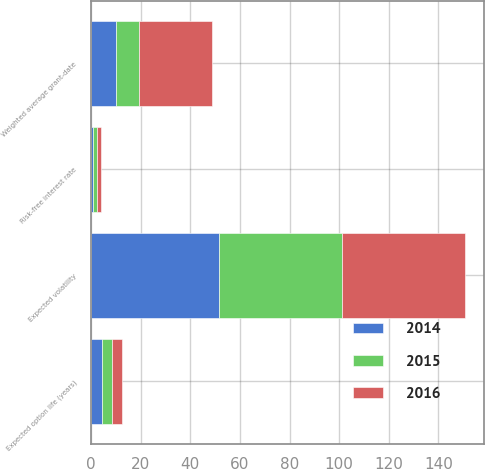Convert chart. <chart><loc_0><loc_0><loc_500><loc_500><stacked_bar_chart><ecel><fcel>Weighted average grant-date<fcel>Risk-free interest rate<fcel>Expected option life (years)<fcel>Expected volatility<nl><fcel>2016<fcel>29.57<fcel>1.55<fcel>4.15<fcel>49.7<nl><fcel>2015<fcel>9.29<fcel>1.6<fcel>4.19<fcel>49.3<nl><fcel>2014<fcel>9.85<fcel>0.94<fcel>4.25<fcel>51.7<nl></chart> 